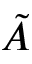Convert formula to latex. <formula><loc_0><loc_0><loc_500><loc_500>\tilde { A }</formula> 